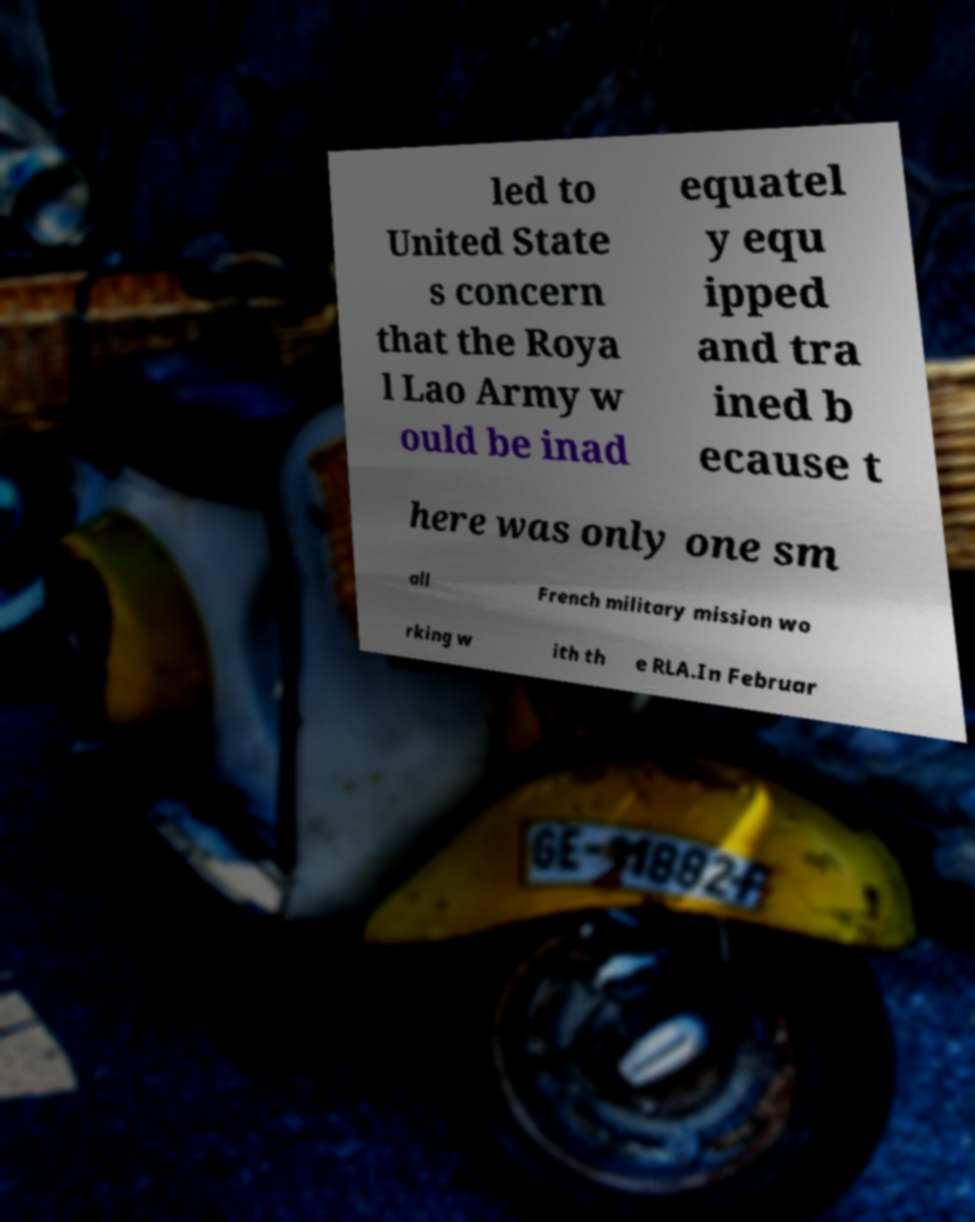Could you assist in decoding the text presented in this image and type it out clearly? led to United State s concern that the Roya l Lao Army w ould be inad equatel y equ ipped and tra ined b ecause t here was only one sm all French military mission wo rking w ith th e RLA.In Februar 